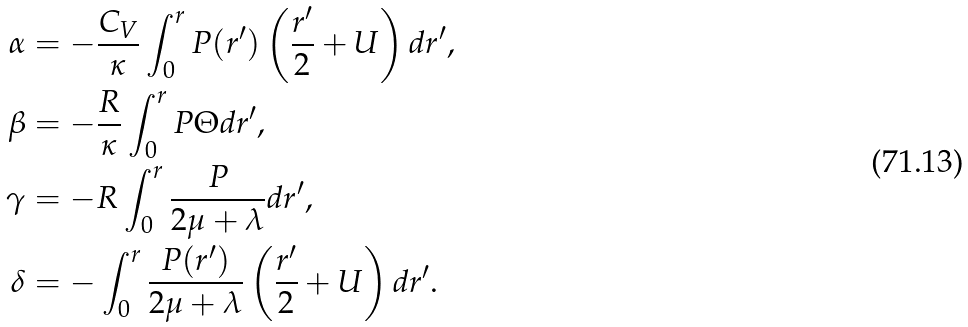Convert formula to latex. <formula><loc_0><loc_0><loc_500><loc_500>\alpha & = - \frac { C _ { V } } { \kappa } \int _ { 0 } ^ { r } P ( r ^ { \prime } ) \left ( \frac { r ^ { \prime } } { 2 } + U \right ) d r ^ { \prime } , \\ \beta & = - \frac { R } { \kappa } \int _ { 0 } ^ { r } P \Theta d r ^ { \prime } , \\ \gamma & = - R \int _ { 0 } ^ { r } \frac { P } { 2 \mu + \lambda } d r ^ { \prime } , \\ \delta & = - \int _ { 0 } ^ { r } \frac { P ( r ^ { \prime } ) } { 2 \mu + \lambda } \left ( \frac { r ^ { \prime } } { 2 } + U \right ) d r ^ { \prime } .</formula> 